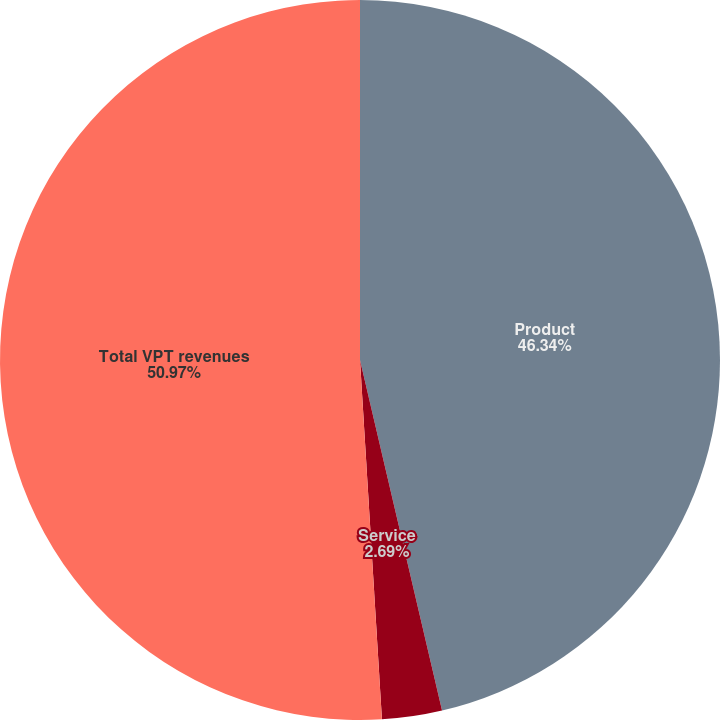Convert chart to OTSL. <chart><loc_0><loc_0><loc_500><loc_500><pie_chart><fcel>Product<fcel>Service<fcel>Total VPT revenues<nl><fcel>46.34%<fcel>2.69%<fcel>50.97%<nl></chart> 